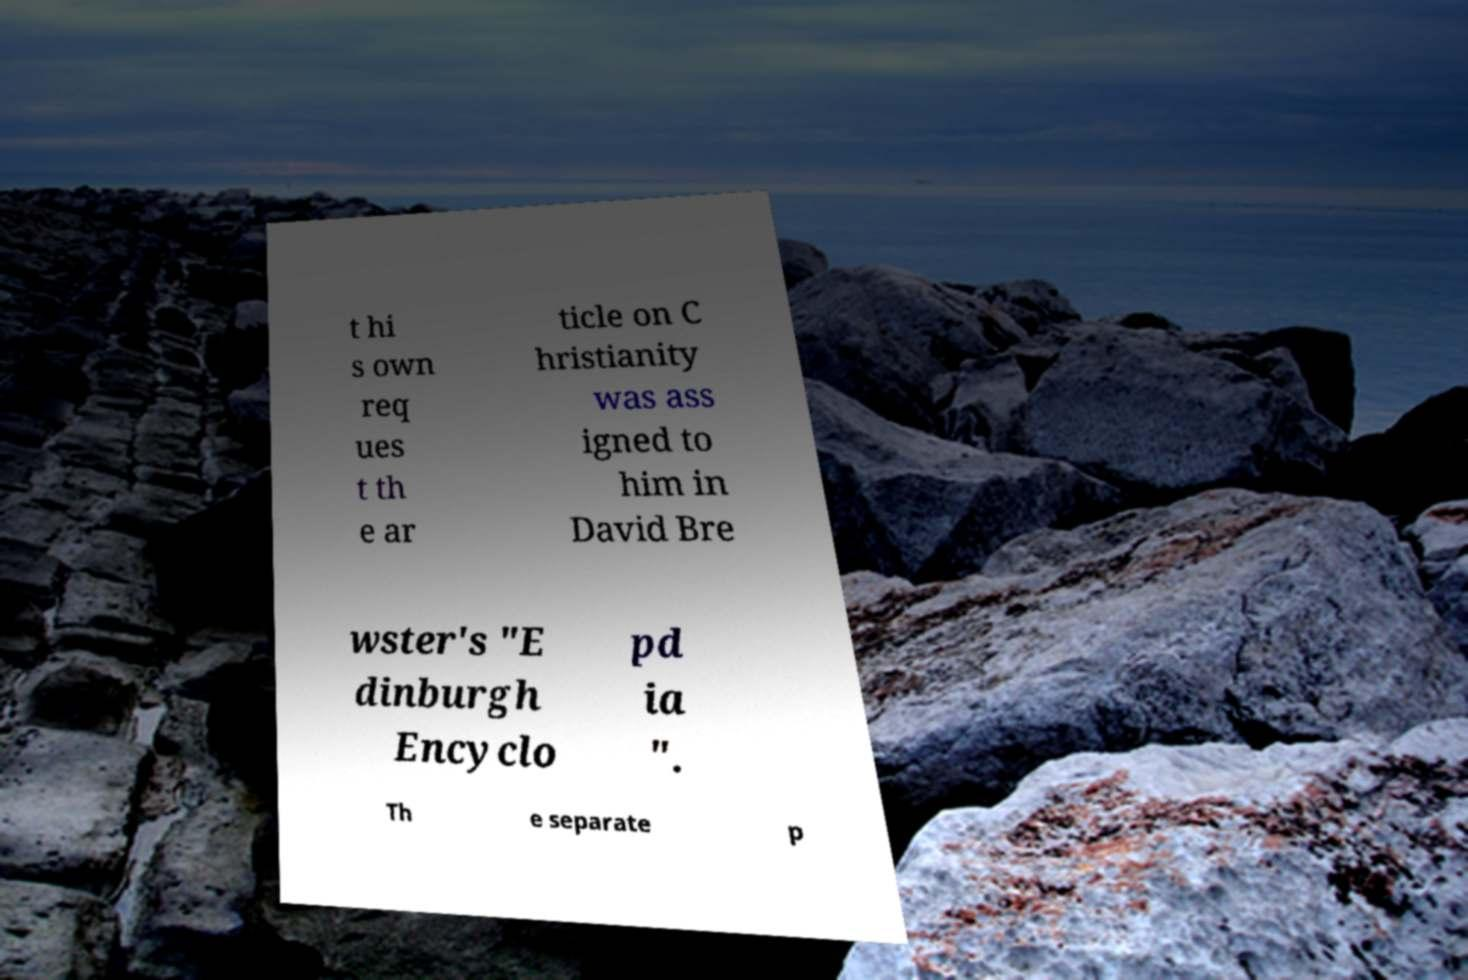What messages or text are displayed in this image? I need them in a readable, typed format. t hi s own req ues t th e ar ticle on C hristianity was ass igned to him in David Bre wster's "E dinburgh Encyclo pd ia ". Th e separate p 